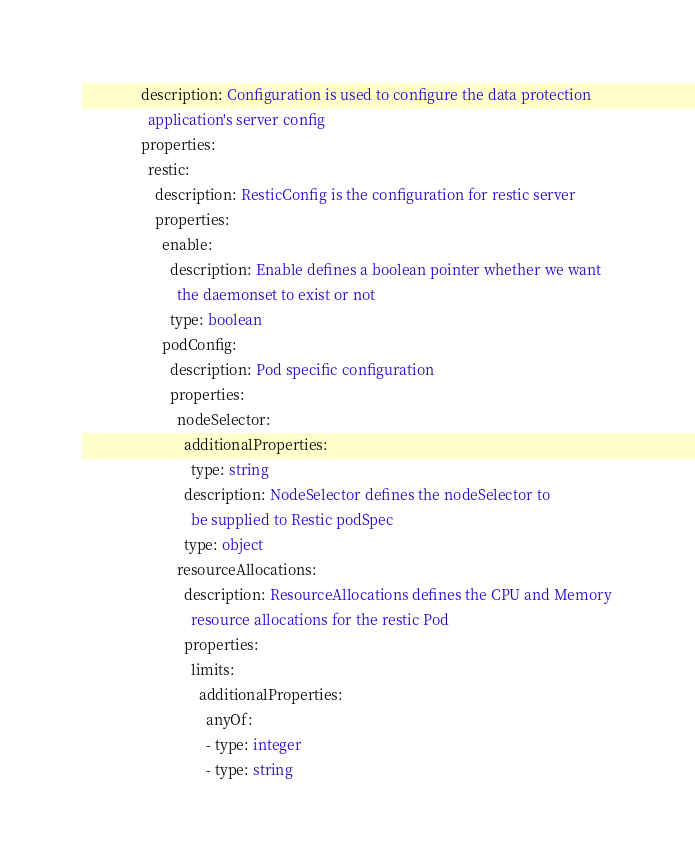Convert code to text. <code><loc_0><loc_0><loc_500><loc_500><_YAML_>                description: Configuration is used to configure the data protection
                  application's server config
                properties:
                  restic:
                    description: ResticConfig is the configuration for restic server
                    properties:
                      enable:
                        description: Enable defines a boolean pointer whether we want
                          the daemonset to exist or not
                        type: boolean
                      podConfig:
                        description: Pod specific configuration
                        properties:
                          nodeSelector:
                            additionalProperties:
                              type: string
                            description: NodeSelector defines the nodeSelector to
                              be supplied to Restic podSpec
                            type: object
                          resourceAllocations:
                            description: ResourceAllocations defines the CPU and Memory
                              resource allocations for the restic Pod
                            properties:
                              limits:
                                additionalProperties:
                                  anyOf:
                                  - type: integer
                                  - type: string</code> 